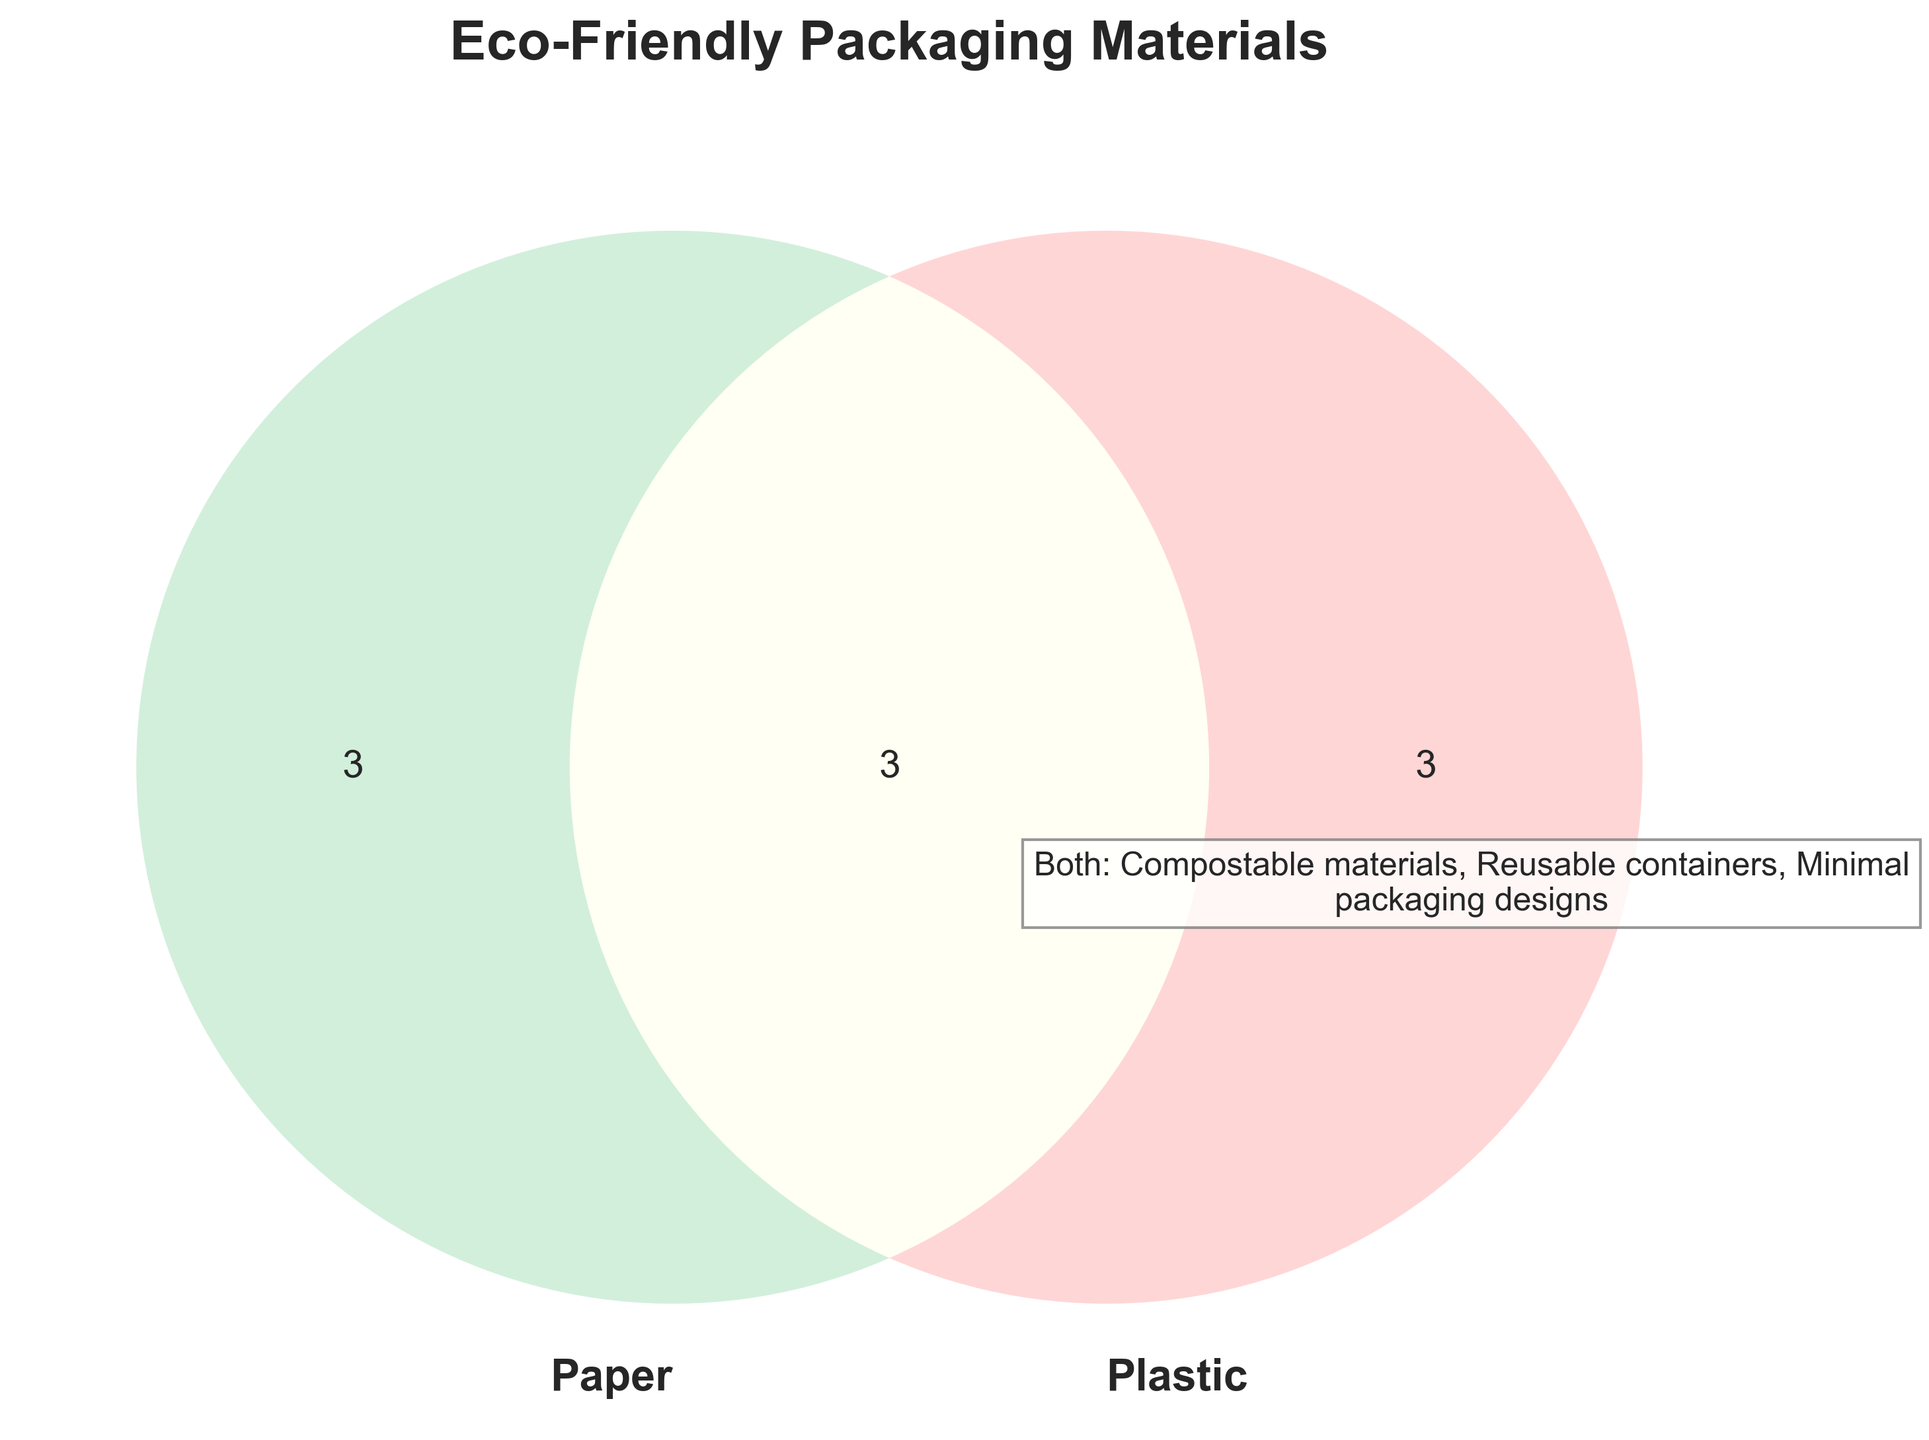What is the title of the Venn Diagram? Look at the top of the diagram where the title is located. It reads "Eco-Friendly Packaging Materials".
Answer: Eco-Friendly Packaging Materials What colors are used for the circles representing Paper and Plastic? The circle representing Paper is greenish while the circle for Plastic is pinkish.
Answer: Green and Pink How many items are listed under the category Paper? Count the number of items within the section labeled Paper.
Answer: 3 What category does "Biodegradable plastics" belong to? Locate "Biodegradable plastics" within the Venn Diagram and see which circle it falls into.
Answer: Plastic How many items belong to the intersection of Paper and Plastic? Look at the central overlapping section between Paper and Plastic.
Answer: 3 Which materials are listed under both Paper and Plastic? Look at the intersection area of the Venn Diagram and read the items listed there.
Answer: Compostable materials, Reusable containers, Minimal packaging designs Are there more items listed under Paper or Plastic? Compare the number of items in the Paper circle and the Plastic circle.
Answer: Same number If you combine all items under Paper and Both, how many unique materials are there? Count the items in the Paper-only section and add the items in the Both section.
Answer: 6 Which category includes "Recycled cardboard" and "Plant-based plastics"? Identify "Recycled cardboard" in the Paper circle and "Plant-based plastics" in the Plastic circle.
Answer: Paper and Plastic respectively What is a shared characteristic of the materials in the intersection? Think about what the common properties might be given the context of eco-friendly packaging materials, like being reusable or biodegradable.
Answer: Eco-friendly attributes 